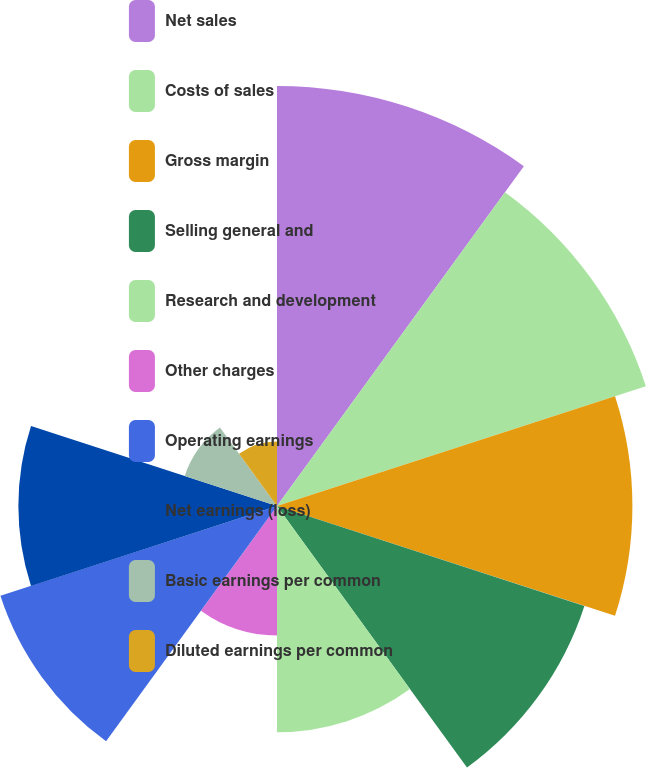Convert chart. <chart><loc_0><loc_0><loc_500><loc_500><pie_chart><fcel>Net sales<fcel>Costs of sales<fcel>Gross margin<fcel>Selling general and<fcel>Research and development<fcel>Other charges<fcel>Operating earnings<fcel>Net earnings (loss)<fcel>Basic earnings per common<fcel>Diluted earnings per common<nl><fcel>16.45%<fcel>15.19%<fcel>13.92%<fcel>12.66%<fcel>8.86%<fcel>5.07%<fcel>11.39%<fcel>10.13%<fcel>3.8%<fcel>2.53%<nl></chart> 